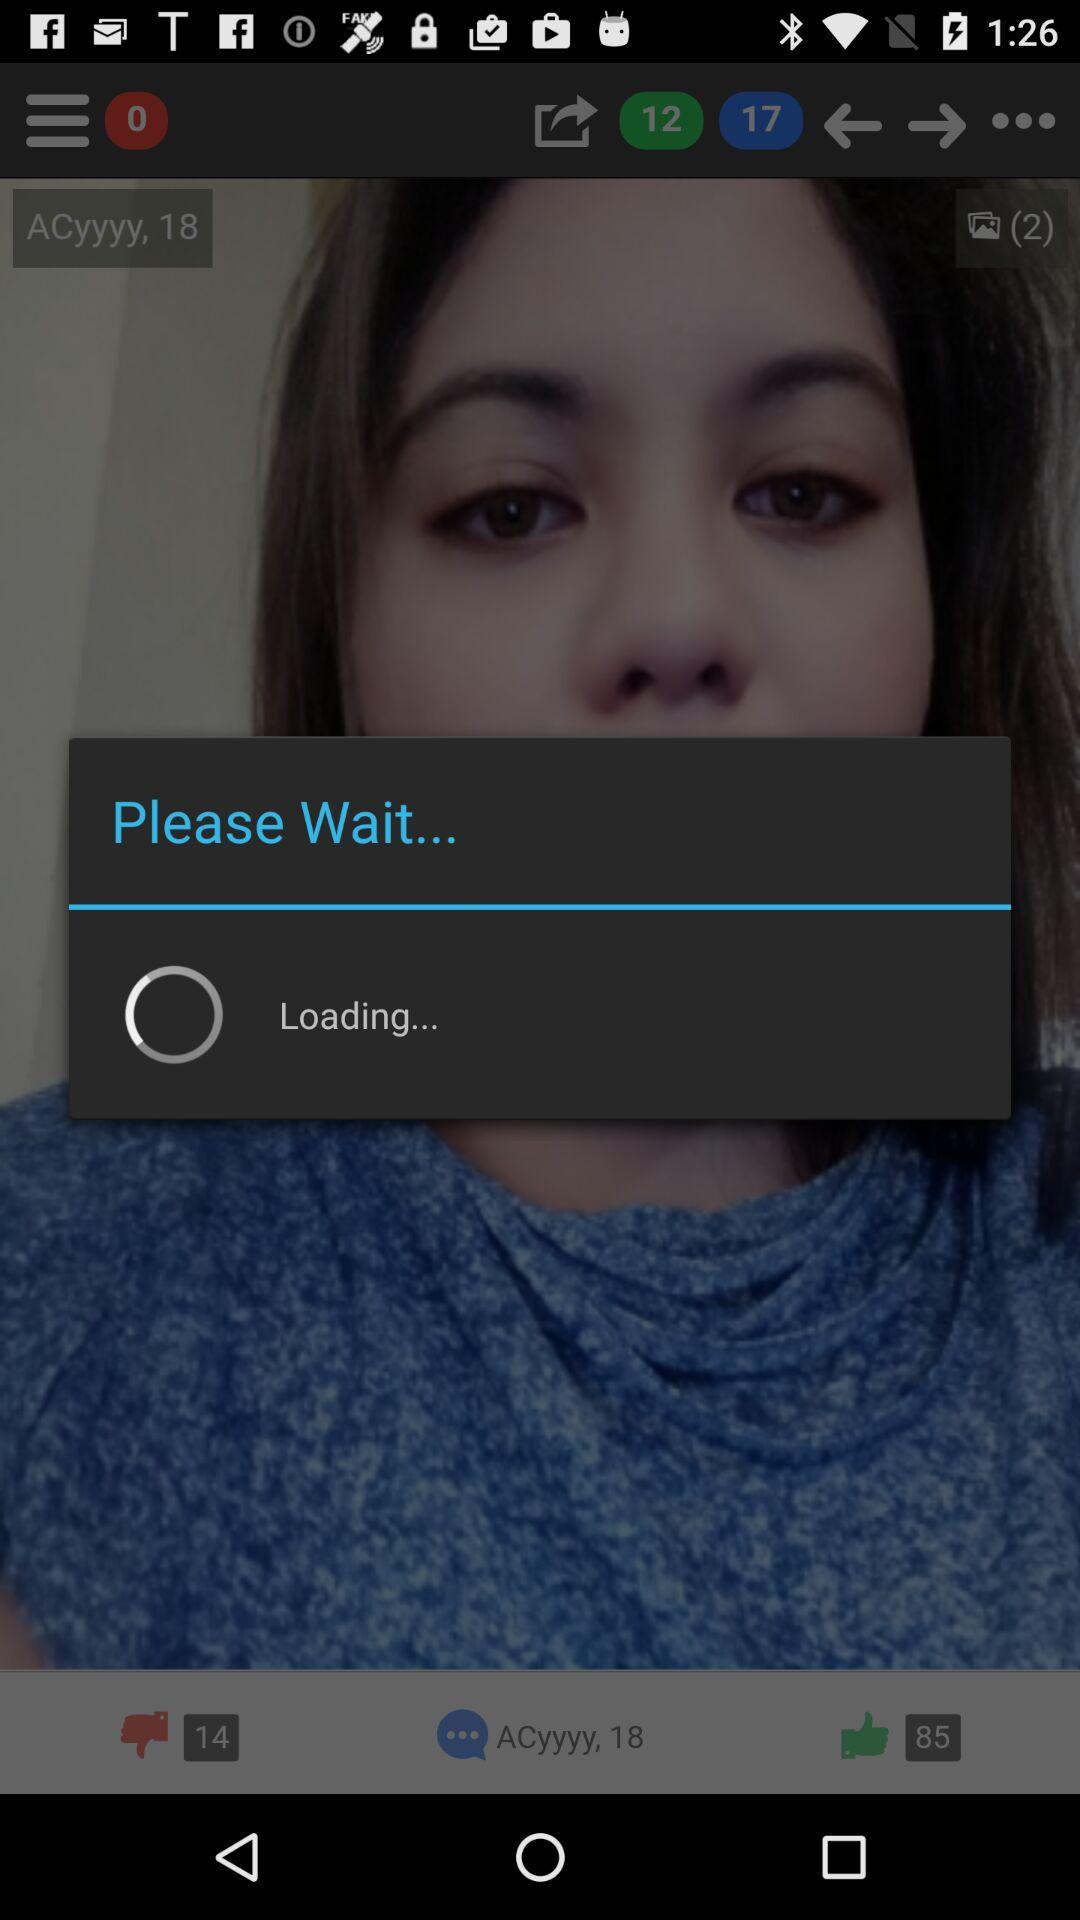Which information will "I Find you" receive? "I Find you" will receive public profile, email address and birthday. 